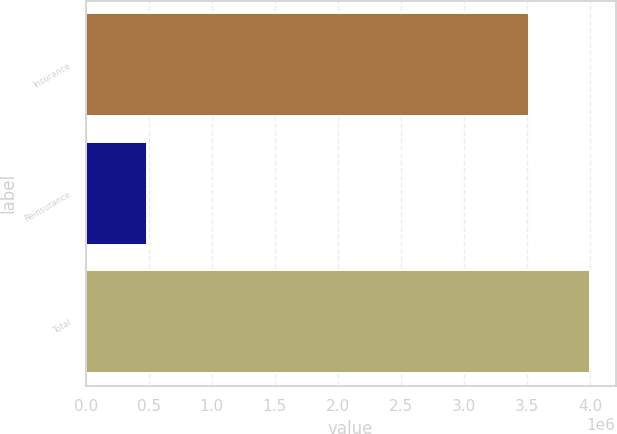<chart> <loc_0><loc_0><loc_500><loc_500><bar_chart><fcel>Insurance<fcel>Reinsurance<fcel>Total<nl><fcel>3.517e+06<fcel>485352<fcel>4.00235e+06<nl></chart> 